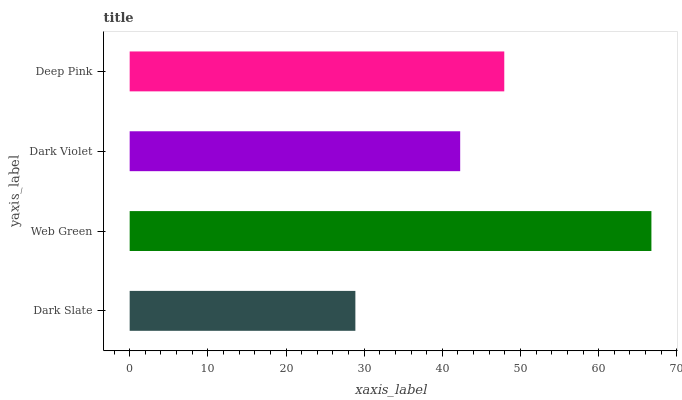Is Dark Slate the minimum?
Answer yes or no. Yes. Is Web Green the maximum?
Answer yes or no. Yes. Is Dark Violet the minimum?
Answer yes or no. No. Is Dark Violet the maximum?
Answer yes or no. No. Is Web Green greater than Dark Violet?
Answer yes or no. Yes. Is Dark Violet less than Web Green?
Answer yes or no. Yes. Is Dark Violet greater than Web Green?
Answer yes or no. No. Is Web Green less than Dark Violet?
Answer yes or no. No. Is Deep Pink the high median?
Answer yes or no. Yes. Is Dark Violet the low median?
Answer yes or no. Yes. Is Web Green the high median?
Answer yes or no. No. Is Deep Pink the low median?
Answer yes or no. No. 